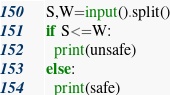<code> <loc_0><loc_0><loc_500><loc_500><_Python_>S,W=input().split()
if S<=W:
  print(unsafe)
else:
  print(safe)</code> 